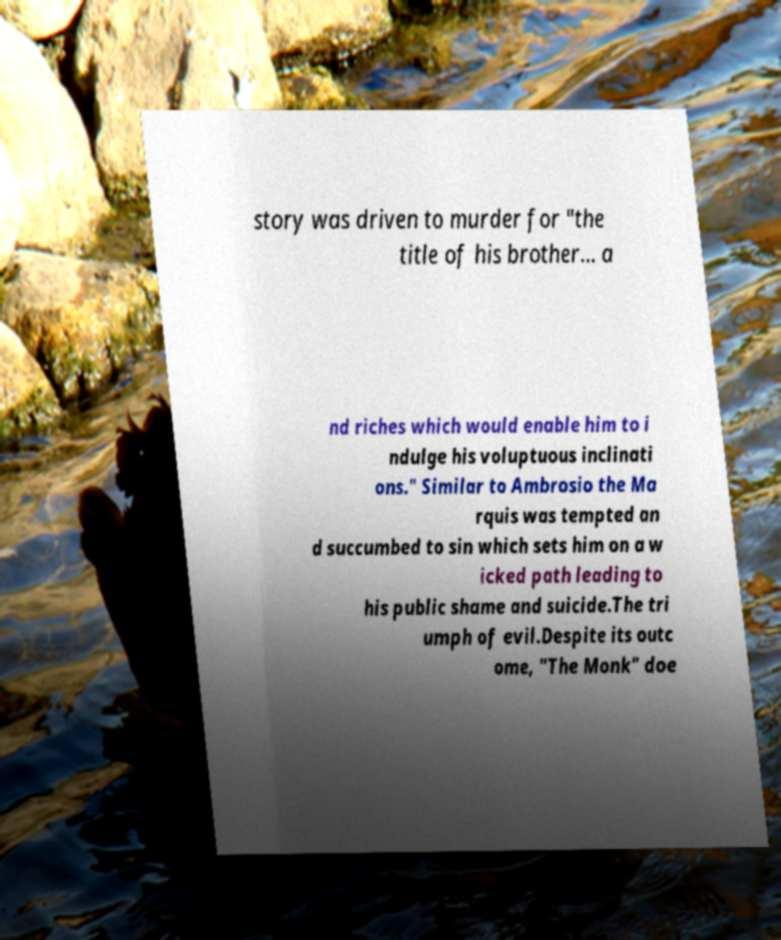Can you accurately transcribe the text from the provided image for me? story was driven to murder for "the title of his brother… a nd riches which would enable him to i ndulge his voluptuous inclinati ons." Similar to Ambrosio the Ma rquis was tempted an d succumbed to sin which sets him on a w icked path leading to his public shame and suicide.The tri umph of evil.Despite its outc ome, "The Monk" doe 